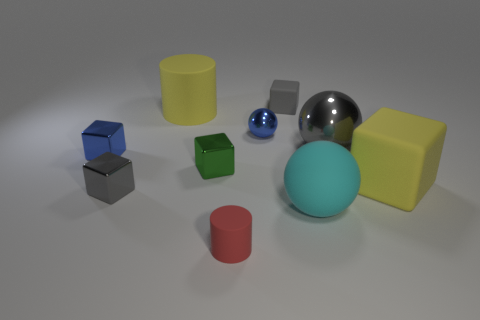How many gray objects are either small metal balls or large metallic balls?
Your answer should be compact. 1. What number of other rubber things are the same size as the cyan thing?
Keep it short and to the point. 2. Do the tiny gray cube that is in front of the yellow matte block and the big gray ball have the same material?
Offer a very short reply. Yes. There is a tiny metal object right of the small cylinder; is there a green metal cube behind it?
Your answer should be compact. No. What material is the small blue object that is the same shape as the cyan rubber object?
Provide a succinct answer. Metal. Are there more red rubber cylinders that are in front of the red rubber cylinder than tiny red objects behind the big gray metallic thing?
Your answer should be very brief. No. There is another big object that is made of the same material as the green thing; what shape is it?
Make the answer very short. Sphere. Is the number of yellow cylinders that are to the left of the blue metallic block greater than the number of cyan rubber balls?
Offer a very short reply. No. How many other metallic objects have the same color as the big shiny object?
Offer a very short reply. 1. How many other objects are the same color as the big matte cube?
Offer a terse response. 1. 